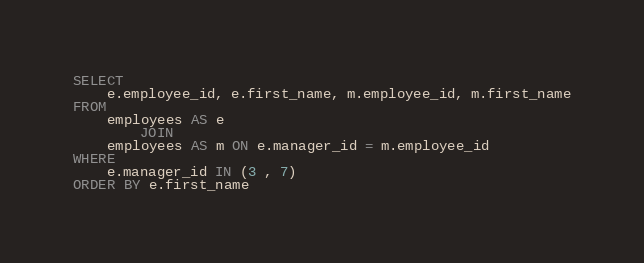Convert code to text. <code><loc_0><loc_0><loc_500><loc_500><_SQL_>SELECT 
    e.employee_id, e.first_name, m.employee_id, m.first_name
FROM
    employees AS e
        JOIN
    employees AS m ON e.manager_id = m.employee_id
WHERE
    e.manager_id IN (3 , 7)
ORDER BY e.first_name</code> 